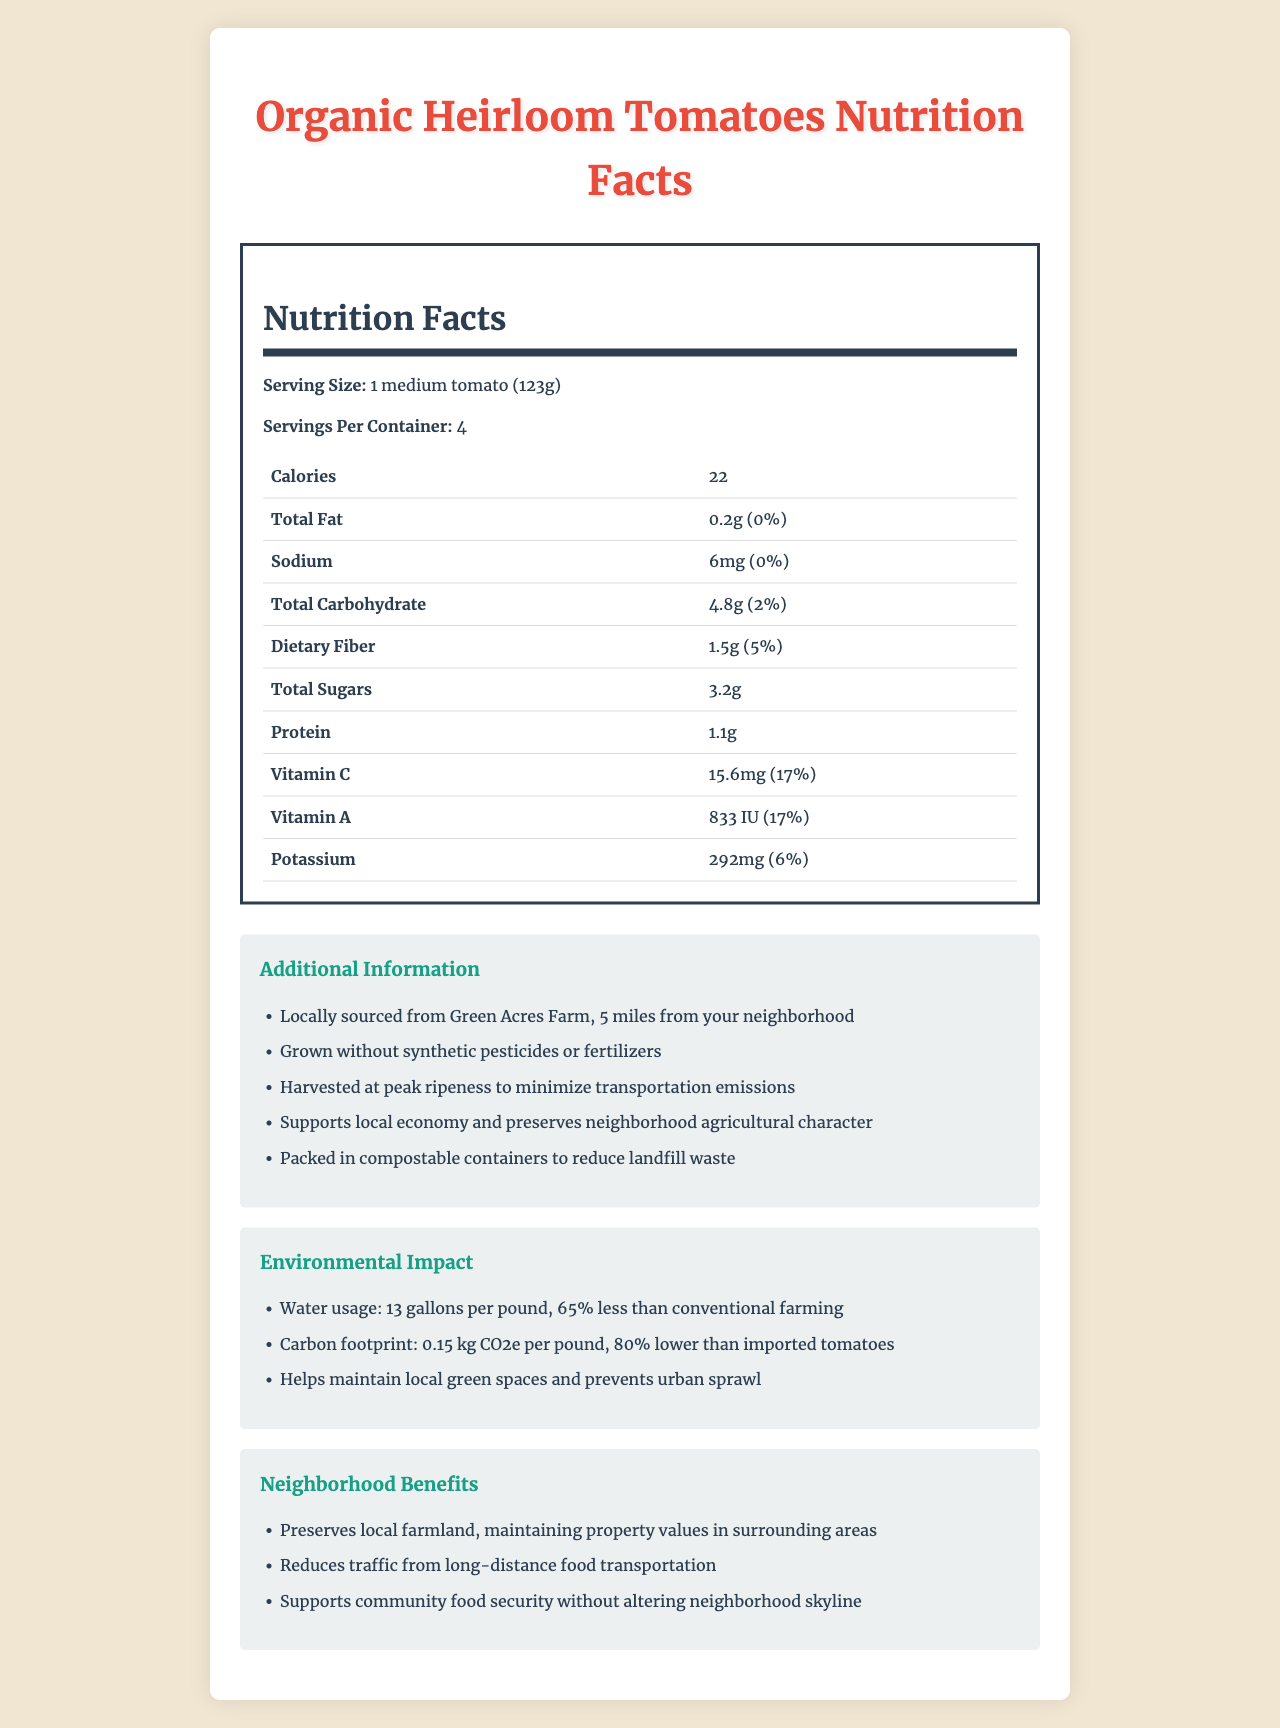who is the supplier of the Organic Heirloom Tomatoes? The Additional Information section notes that the tomatoes are locally sourced from Green Acres Farm, 5 miles from the neighborhood.
Answer: Green Acres Farm what is the serving size for the Organic Heirloom Tomatoes? The Nutrition Facts section lists the serving size as "1 medium tomato (123g)".
Answer: 1 medium tomato (123g) how many calories are there per serving? The table in the Nutrition Facts section states that there are 22 calories per serving.
Answer: 22 what percentage of daily Vitamin C does one serving provide? In the Nutrition Facts, Vitamin C is listed as providing 17% of the daily value per serving.
Answer: 17% how does consuming locally-sourced organic produce benefit the environment? The Environmental Impact section states that water usage is 65% less, and the carbon footprint is 80% lower than imported tomatoes.
Answer: Reduced water usage and lower carbon footprint which vitamin has the same daily value percentage as Vitamin C? A. Vitamin A B. Potassium C. Sodium D. Total Fat Both Vitamin C and Vitamin A have a daily value percentage of 17%.
Answer: A how much potassium is found in one serving? A. 292mg B. 15.6mg C. 1.5g D. 833 IU The Nutrition Facts section lists potassium as 292mg per serving.
Answer: A are these tomatoes grown with synthetic pesticides or fertilizers? The Additional Information section specifies that these tomatoes are grown without synthetic pesticides or fertilizers.
Answer: No does the document indicate that the tomatoes help in reducing traffic from long-distance food transportation? The Neighborhood Benefits section mentions that consuming these tomatoes reduces traffic from long-distance food transportation.
Answer: Yes summarize the main idea of the document. It describes the product's nutritional value, environmental impact, and community benefits, highlighting local sourcing and organic farming practices.
Answer: The document provides detailed nutrition facts and benefits of Organic Heirloom Tomatoes, emphasizing their low environmental impact, support for the local economy, and neighborhood benefits. is there information about the price of the Organic Heirloom Tomatoes? The document does not include any details about the price of the tomatoes.
Answer: Not enough information 